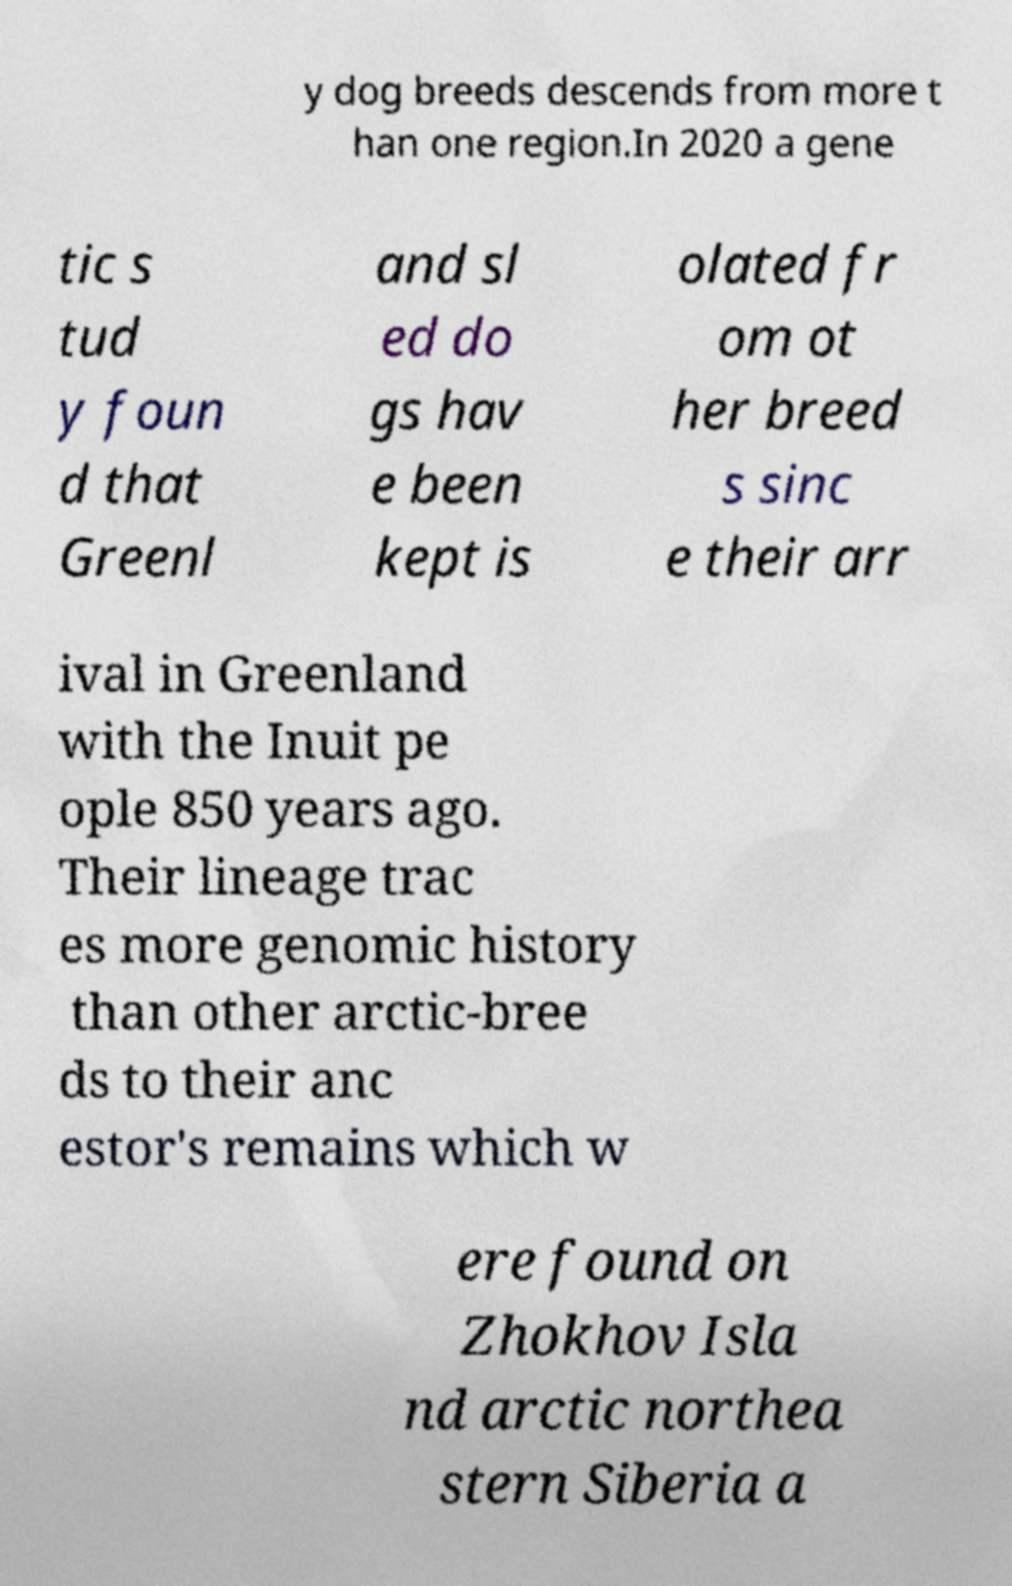Can you accurately transcribe the text from the provided image for me? y dog breeds descends from more t han one region.In 2020 a gene tic s tud y foun d that Greenl and sl ed do gs hav e been kept is olated fr om ot her breed s sinc e their arr ival in Greenland with the Inuit pe ople 850 years ago. Their lineage trac es more genomic history than other arctic-bree ds to their anc estor's remains which w ere found on Zhokhov Isla nd arctic northea stern Siberia a 